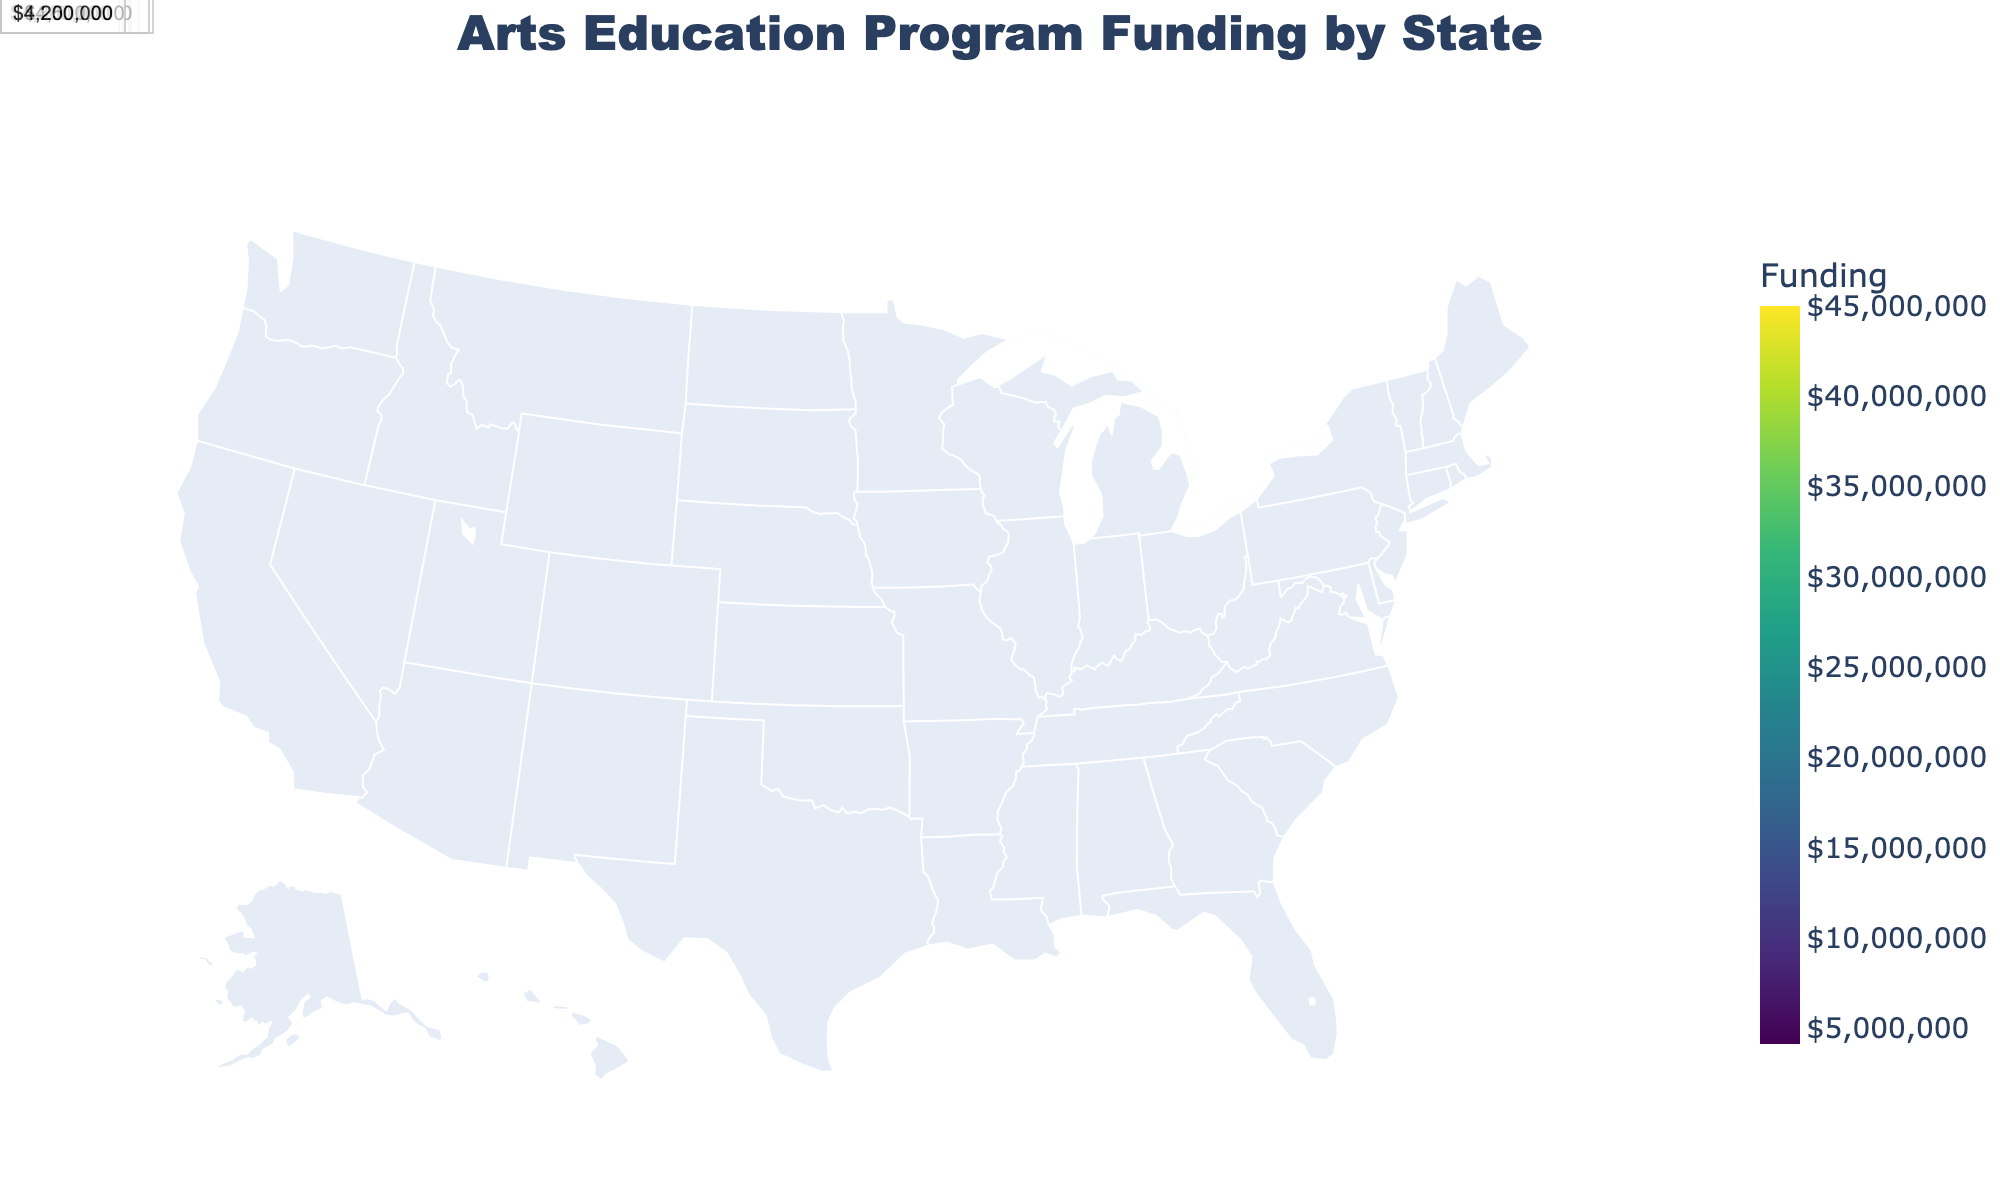How many states are depicted in the figure? There are labels for 20 states in the figure, which corresponds to the number of entries in the data.
Answer: 20 Which state has the highest funding allocation for arts education programs? California is the state with the highest funding allocation as depicted by the darkest shade on the map and the highest numerical value on its label.
Answer: California What is the approximate difference in funding allocation between New York and Texas? New York has $38,000,000, and Texas has $22,000,000. Subtracting the two gives $38,000,000 - $22,000,000.
Answer: $16,000,000 How does Florida's funding allocation compare to Ohio's? Florida has $18,000,000 while Ohio has $12,500,000. Florida's funding is higher than Ohio's.
Answer: Florida's is higher What is the sum of the funding allocation for Massachusetts, Washington, and Colorado? Massachusetts has $10,500,000, Washington has $9,800,000, and Colorado has $8,200,000. Adding these amounts together gives $10,500,000 + $9,800,000 + $8,200,000.
Answer: $28,500,000 Which states have funding allocations below $5,000,000? The states below $5,000,000 can be identified by their labels: Georgia, New Jersey, Virginia, Arizona, North Carolina, and Connecticut.
Answer: Georgia, New Jersey, Virginia, Arizona, North Carolina, Connecticut What is the median funding allocation value among the states listed? The data points are sorted from smallest to largest, placed in an even sequence you find the middle pair and average them. Thus, the middle values are for Michigan and Massachusetts ($11,000,000 and $10,500,000). The median is ($11,000,000 + $10,500,000) / 2.
Answer: $10,750,000 Is there any state with a funding allocation exactly equal to $10,000,000? The funding labels on the map indicate that no state has an allocation exactly equal to $10,000,000.
Answer: No Which state falls between Illinois and Pennsylvania in terms of funding allocation? Illinois has $16,500,000 and Pennsylvania has $15,000,000. The state between them in terms of funding amount is Pennsylvania.
Answer: Pennsylvania How do the funding allocations in western states (California, Washington, Oregon) compare to those in eastern states (New York, Pennsylvania, Massachusetts)? Adding the western states' totals: $45,000,000 + $9,800,000 + $6,800,000 = $61,600,000. Adding the eastern states' totals: $38,000,000 + $15,000,000 + $10,500,000 = $63,500,000. The total funding is slightly higher in the eastern states.
Answer: Higher in eastern states 